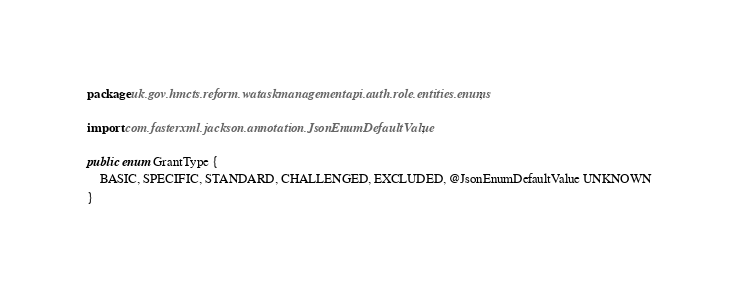Convert code to text. <code><loc_0><loc_0><loc_500><loc_500><_Java_>package uk.gov.hmcts.reform.wataskmanagementapi.auth.role.entities.enums;

import com.fasterxml.jackson.annotation.JsonEnumDefaultValue;

public enum GrantType {
    BASIC, SPECIFIC, STANDARD, CHALLENGED, EXCLUDED, @JsonEnumDefaultValue UNKNOWN
}
</code> 